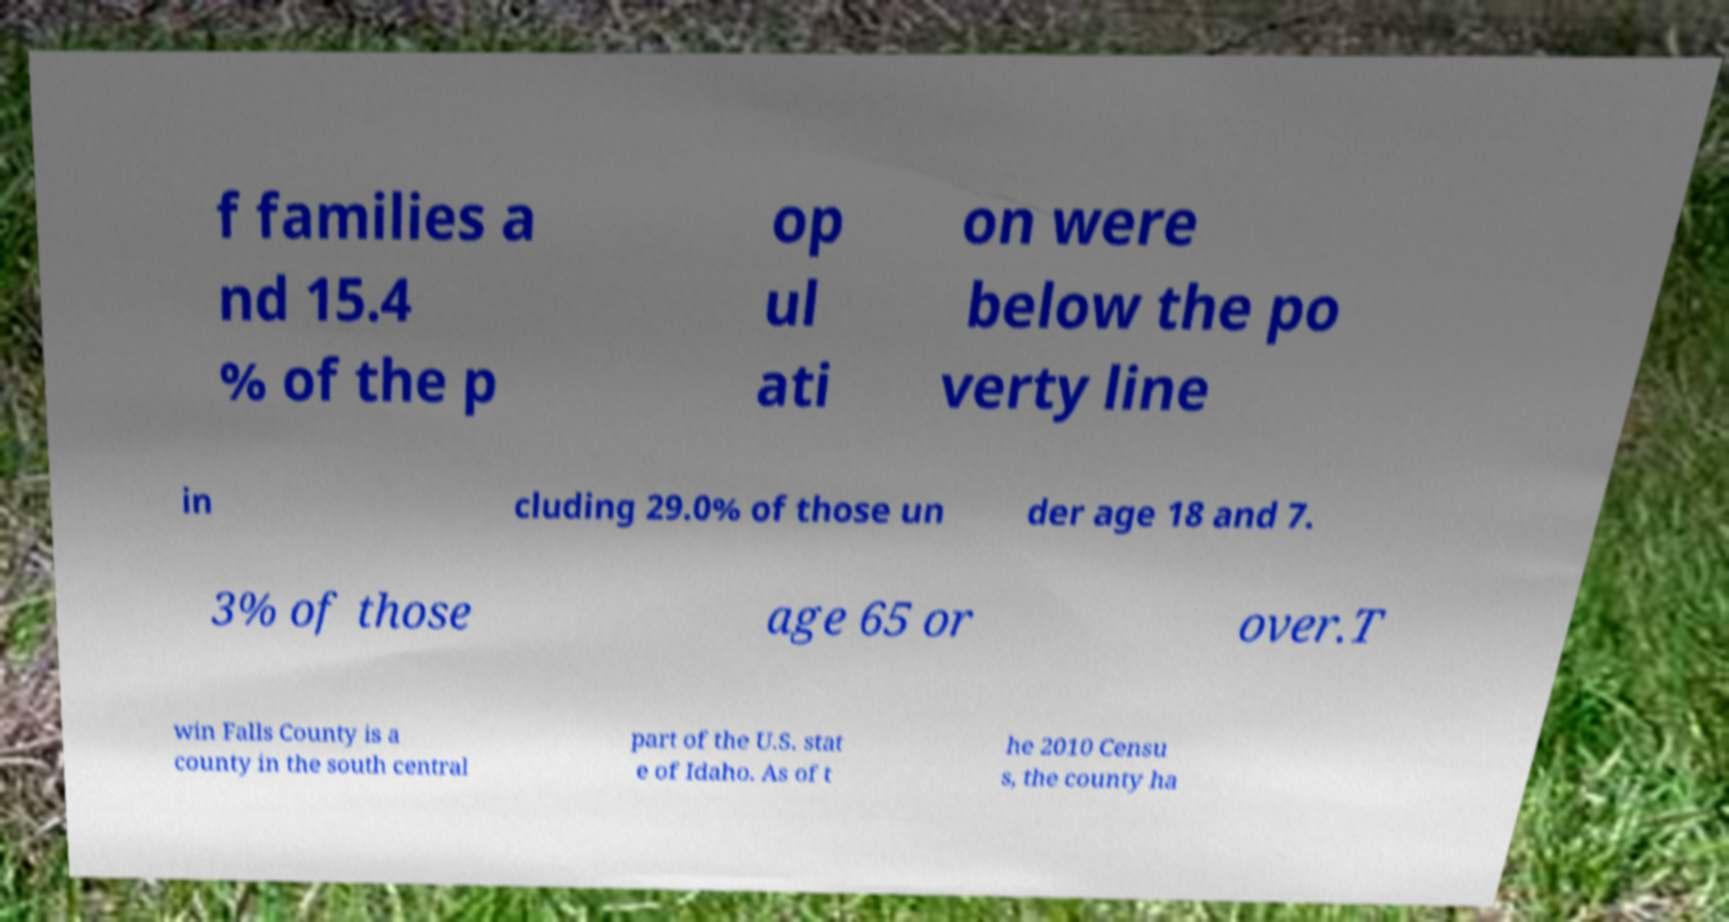I need the written content from this picture converted into text. Can you do that? f families a nd 15.4 % of the p op ul ati on were below the po verty line in cluding 29.0% of those un der age 18 and 7. 3% of those age 65 or over.T win Falls County is a county in the south central part of the U.S. stat e of Idaho. As of t he 2010 Censu s, the county ha 